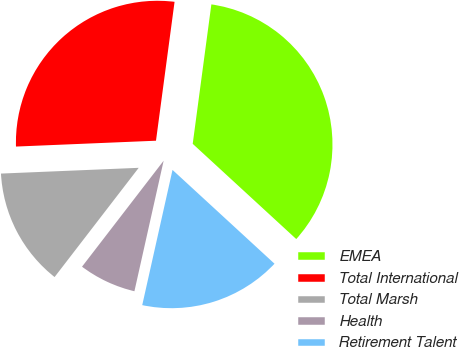Convert chart. <chart><loc_0><loc_0><loc_500><loc_500><pie_chart><fcel>EMEA<fcel>Total International<fcel>Total Marsh<fcel>Health<fcel>Retirement Talent<nl><fcel>34.72%<fcel>27.78%<fcel>13.89%<fcel>6.94%<fcel>16.67%<nl></chart> 